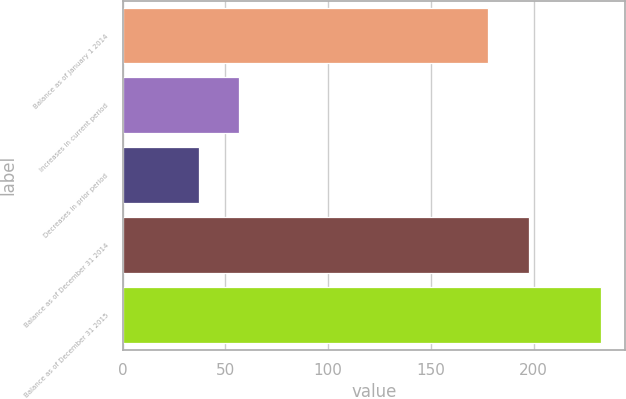Convert chart to OTSL. <chart><loc_0><loc_0><loc_500><loc_500><bar_chart><fcel>Balance as of January 1 2014<fcel>Increases in current period<fcel>Decreases in prior period<fcel>Balance as of December 31 2014<fcel>Balance as of December 31 2015<nl><fcel>178<fcel>56.6<fcel>37<fcel>197.6<fcel>233<nl></chart> 